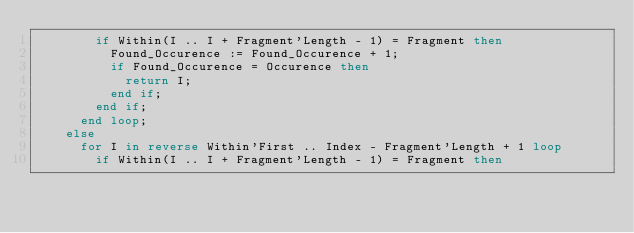<code> <loc_0><loc_0><loc_500><loc_500><_Ada_>        if Within(I .. I + Fragment'Length - 1) = Fragment then
          Found_Occurence := Found_Occurence + 1;
          if Found_Occurence = Occurence then
            return I;
          end if;
        end if;
      end loop;
    else
      for I in reverse Within'First .. Index - Fragment'Length + 1 loop
        if Within(I .. I + Fragment'Length - 1) = Fragment then</code> 